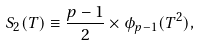Convert formula to latex. <formula><loc_0><loc_0><loc_500><loc_500>S _ { 2 } ( T ) \equiv \frac { p - 1 } { 2 } \times \phi _ { p - 1 } ( T ^ { 2 } ) ,</formula> 